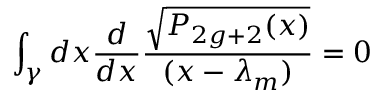<formula> <loc_0><loc_0><loc_500><loc_500>\int _ { \gamma } d x { \frac { d } { d x } } { \frac { \sqrt { P _ { 2 g + 2 } ( x ) } } { ( x - \lambda _ { m } ) } } = 0</formula> 